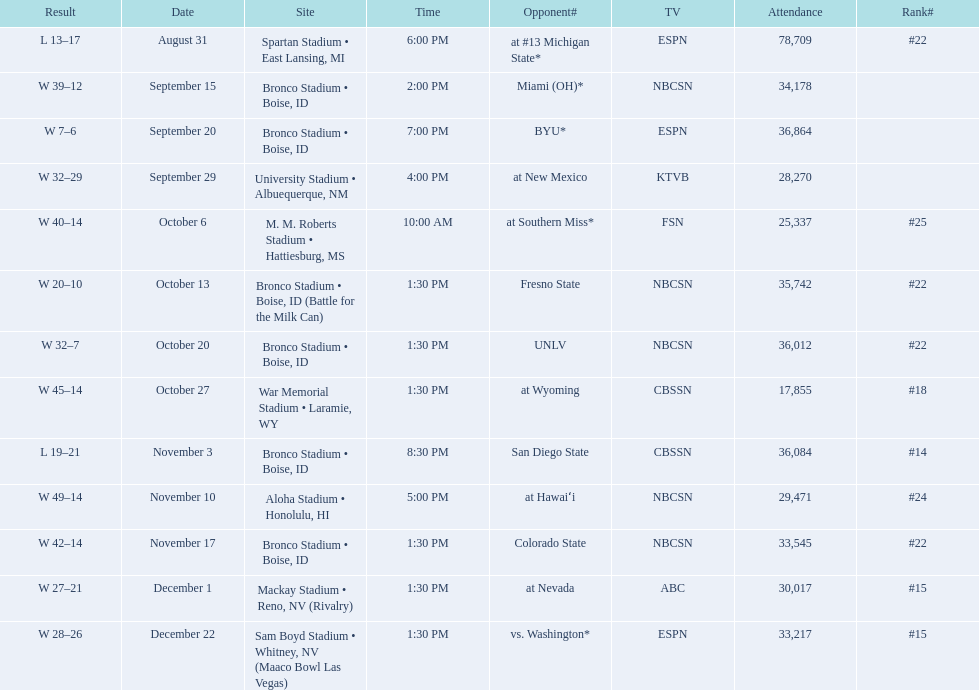What are the opponents to the  2012 boise state broncos football team? At #13 michigan state*, miami (oh)*, byu*, at new mexico, at southern miss*, fresno state, unlv, at wyoming, san diego state, at hawaiʻi, colorado state, at nevada, vs. washington*. Which is the highest ranked of the teams? San Diego State. 